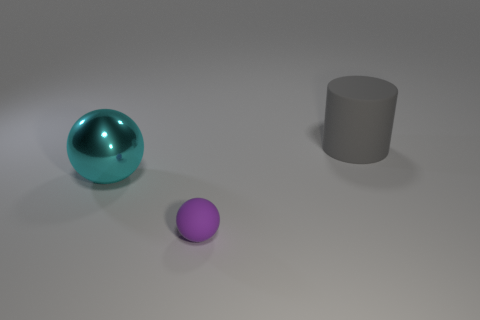Are there any other things that are the same size as the purple rubber object?
Make the answer very short. No. Is there a cyan thing of the same size as the purple object?
Your answer should be compact. No. What number of rubber things are both in front of the large matte cylinder and right of the tiny purple rubber thing?
Give a very brief answer. 0. What number of cylinders are on the left side of the small purple object?
Provide a succinct answer. 0. Are there any large gray objects of the same shape as the purple thing?
Your answer should be very brief. No. Is the shape of the big cyan thing the same as the big thing right of the purple rubber ball?
Your response must be concise. No. How many cylinders are either cyan things or purple things?
Provide a succinct answer. 0. What shape is the big object in front of the large rubber cylinder?
Your answer should be very brief. Sphere. What number of large gray cylinders have the same material as the small purple sphere?
Provide a succinct answer. 1. Is the number of balls that are in front of the large cyan metallic object less than the number of big purple objects?
Make the answer very short. No. 